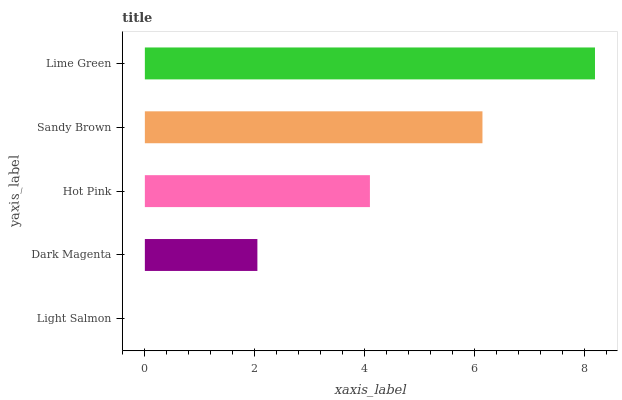Is Light Salmon the minimum?
Answer yes or no. Yes. Is Lime Green the maximum?
Answer yes or no. Yes. Is Dark Magenta the minimum?
Answer yes or no. No. Is Dark Magenta the maximum?
Answer yes or no. No. Is Dark Magenta greater than Light Salmon?
Answer yes or no. Yes. Is Light Salmon less than Dark Magenta?
Answer yes or no. Yes. Is Light Salmon greater than Dark Magenta?
Answer yes or no. No. Is Dark Magenta less than Light Salmon?
Answer yes or no. No. Is Hot Pink the high median?
Answer yes or no. Yes. Is Hot Pink the low median?
Answer yes or no. Yes. Is Sandy Brown the high median?
Answer yes or no. No. Is Dark Magenta the low median?
Answer yes or no. No. 